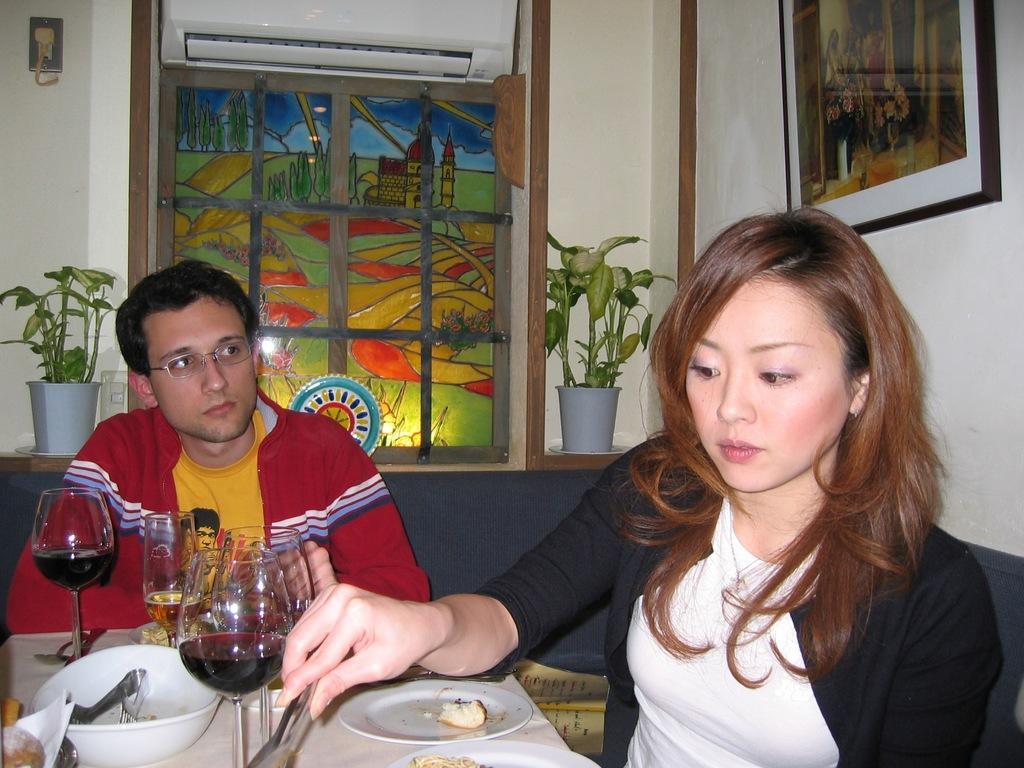Can you describe this image briefly? In this image I see a man and a woman who are sitting and I see that this woman is holding a thing and there are lot of glasses, bowl and plates on the table. In the background I see the wall, 2 plants, an AC and a photo frame. 